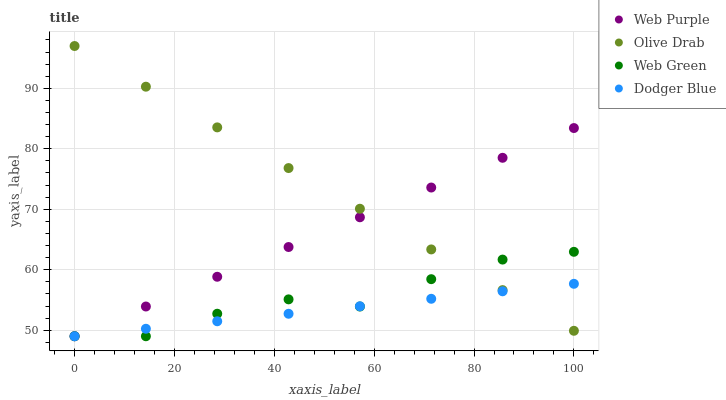Does Dodger Blue have the minimum area under the curve?
Answer yes or no. Yes. Does Olive Drab have the maximum area under the curve?
Answer yes or no. Yes. Does Web Green have the minimum area under the curve?
Answer yes or no. No. Does Web Green have the maximum area under the curve?
Answer yes or no. No. Is Web Purple the smoothest?
Answer yes or no. Yes. Is Web Green the roughest?
Answer yes or no. Yes. Is Dodger Blue the smoothest?
Answer yes or no. No. Is Dodger Blue the roughest?
Answer yes or no. No. Does Web Purple have the lowest value?
Answer yes or no. Yes. Does Olive Drab have the lowest value?
Answer yes or no. No. Does Olive Drab have the highest value?
Answer yes or no. Yes. Does Web Green have the highest value?
Answer yes or no. No. Does Web Green intersect Web Purple?
Answer yes or no. Yes. Is Web Green less than Web Purple?
Answer yes or no. No. Is Web Green greater than Web Purple?
Answer yes or no. No. 